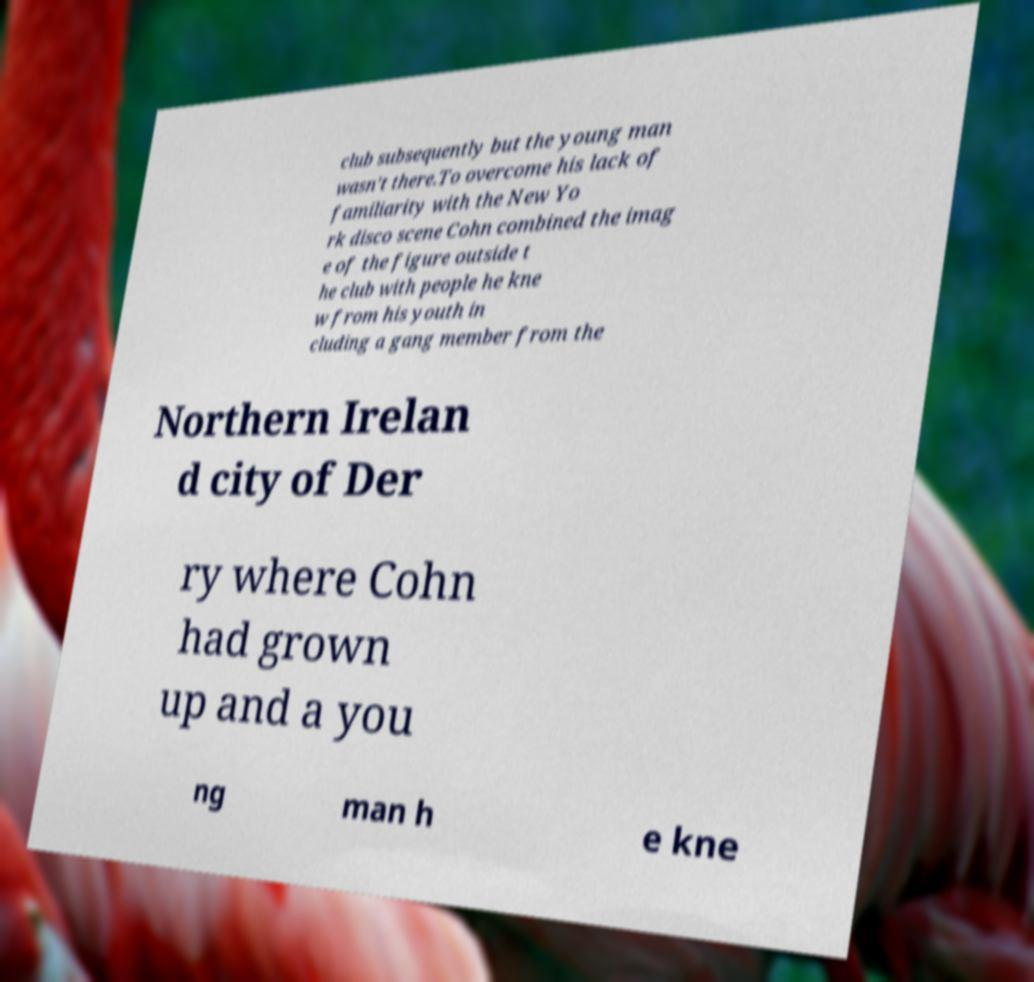There's text embedded in this image that I need extracted. Can you transcribe it verbatim? club subsequently but the young man wasn’t there.To overcome his lack of familiarity with the New Yo rk disco scene Cohn combined the imag e of the figure outside t he club with people he kne w from his youth in cluding a gang member from the Northern Irelan d city of Der ry where Cohn had grown up and a you ng man h e kne 